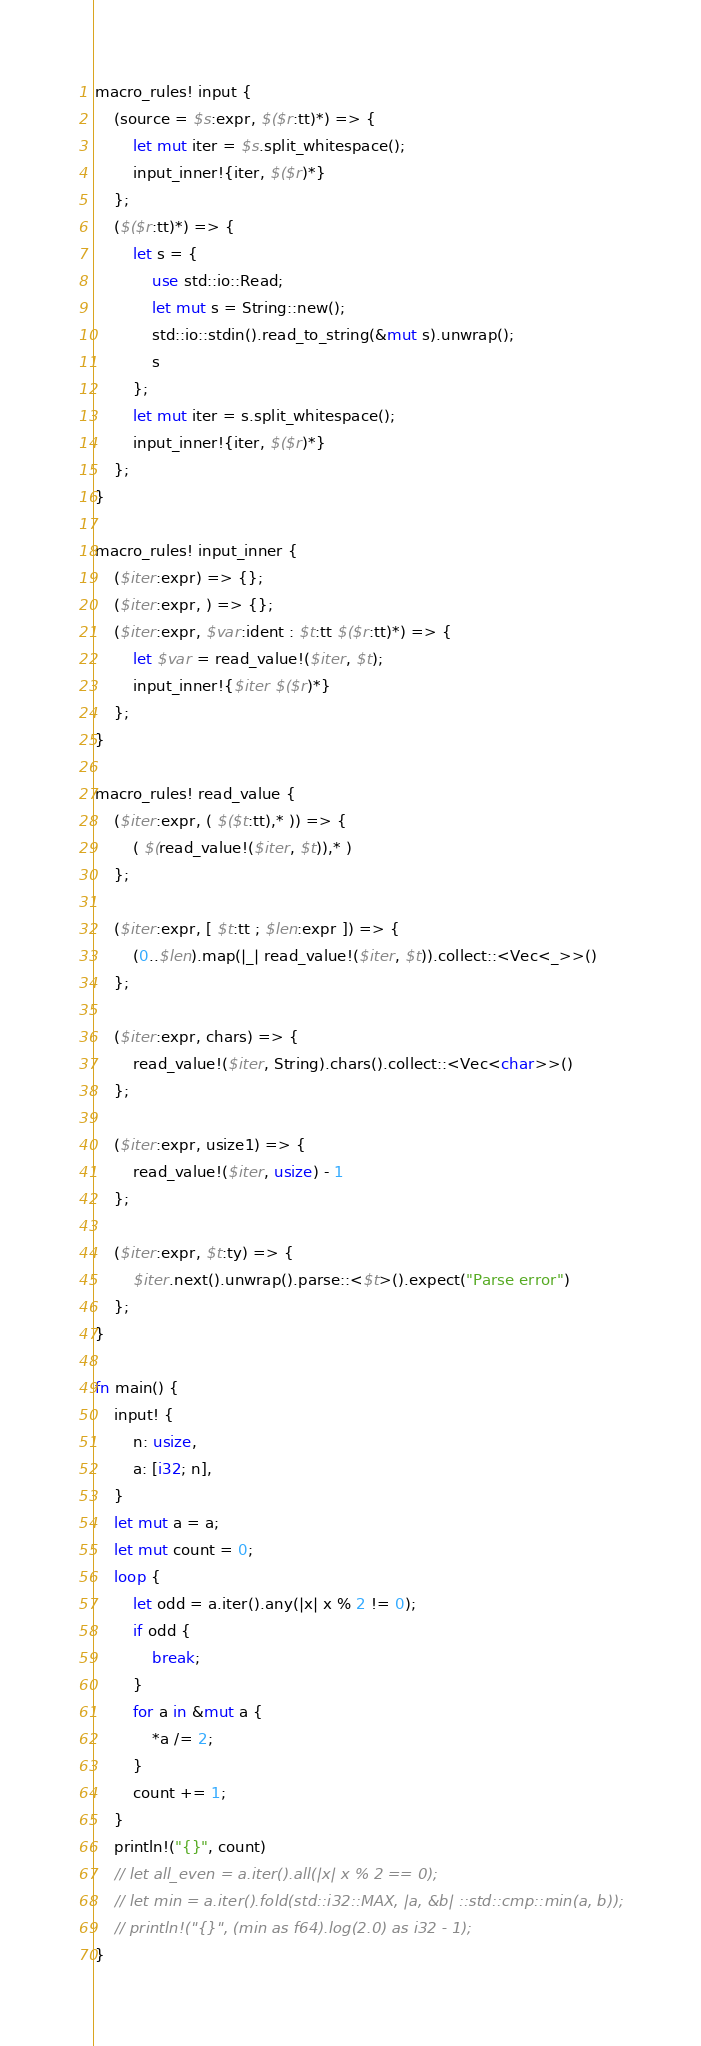<code> <loc_0><loc_0><loc_500><loc_500><_Rust_>macro_rules! input {
    (source = $s:expr, $($r:tt)*) => {
        let mut iter = $s.split_whitespace();
        input_inner!{iter, $($r)*}
    };
    ($($r:tt)*) => {
        let s = {
            use std::io::Read;
            let mut s = String::new();
            std::io::stdin().read_to_string(&mut s).unwrap();
            s
        };
        let mut iter = s.split_whitespace();
        input_inner!{iter, $($r)*}
    };
}

macro_rules! input_inner {
    ($iter:expr) => {};
    ($iter:expr, ) => {};
    ($iter:expr, $var:ident : $t:tt $($r:tt)*) => {
        let $var = read_value!($iter, $t);
        input_inner!{$iter $($r)*}
    };
}

macro_rules! read_value {
    ($iter:expr, ( $($t:tt),* )) => {
        ( $(read_value!($iter, $t)),* )
    };

    ($iter:expr, [ $t:tt ; $len:expr ]) => {
        (0..$len).map(|_| read_value!($iter, $t)).collect::<Vec<_>>()
    };

    ($iter:expr, chars) => {
        read_value!($iter, String).chars().collect::<Vec<char>>()
    };

    ($iter:expr, usize1) => {
        read_value!($iter, usize) - 1
    };

    ($iter:expr, $t:ty) => {
        $iter.next().unwrap().parse::<$t>().expect("Parse error")
    };
}

fn main() {
    input! {
        n: usize,
        a: [i32; n],
    }
    let mut a = a;
    let mut count = 0;
    loop {
        let odd = a.iter().any(|x| x % 2 != 0);
        if odd {
            break;
        }
        for a in &mut a {
            *a /= 2;
        }
        count += 1;
    }
    println!("{}", count)
    // let all_even = a.iter().all(|x| x % 2 == 0);
    // let min = a.iter().fold(std::i32::MAX, |a, &b| ::std::cmp::min(a, b));
    // println!("{}", (min as f64).log(2.0) as i32 - 1);
}
</code> 